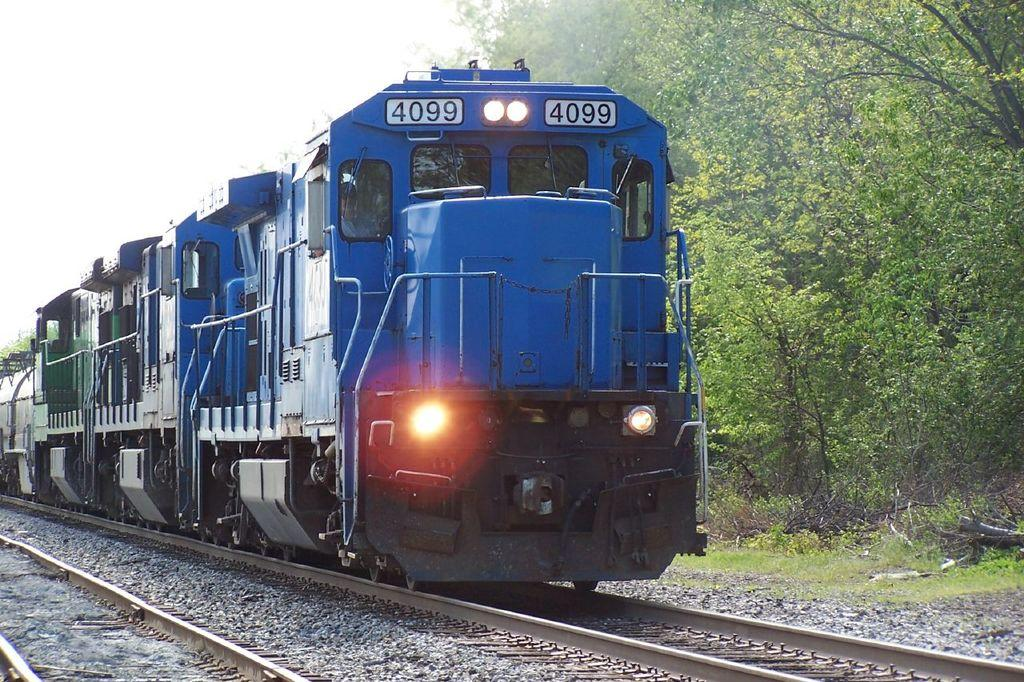What can be seen on the ground in the image? There are tracks in the image. What is moving on the tracks? A train is moving on one of the tracks. What type of vegetation is on the right side of the image? There are trees on the right side of the image. Can you tell me where the grandmother is sitting in the image? There is no grandmother present in the image. What type of ice can be seen melting on the tracks in the image? There is no ice present in the image. 